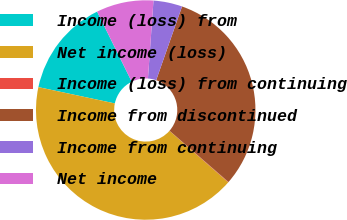<chart> <loc_0><loc_0><loc_500><loc_500><pie_chart><fcel>Income (loss) from<fcel>Net income (loss)<fcel>Income (loss) from continuing<fcel>Income from discontinued<fcel>Income from continuing<fcel>Net income<nl><fcel>14.35%<fcel>41.89%<fcel>0.06%<fcel>31.02%<fcel>4.24%<fcel>8.43%<nl></chart> 